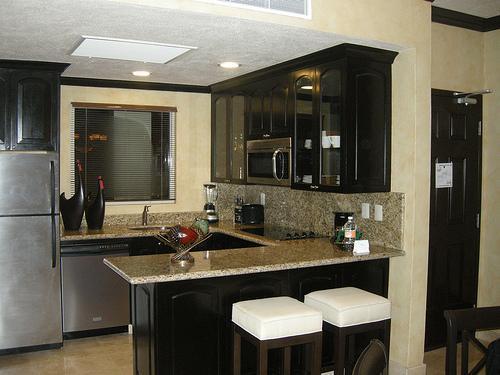How many cabinet doors are above the refrigerator?
Give a very brief answer. 2. 